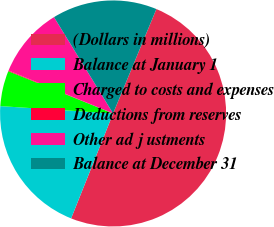Convert chart to OTSL. <chart><loc_0><loc_0><loc_500><loc_500><pie_chart><fcel>(Dollars in millions)<fcel>Balance at January 1<fcel>Charged to costs and expenses<fcel>Deductions from reserves<fcel>Other ad j ustments<fcel>Balance at December 31<nl><fcel>49.8%<fcel>19.98%<fcel>5.07%<fcel>0.1%<fcel>10.04%<fcel>15.01%<nl></chart> 